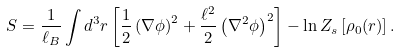<formula> <loc_0><loc_0><loc_500><loc_500>S = \frac { 1 } { \ell _ { B } } \int d ^ { 3 } r \left [ \frac { 1 } { 2 } \left ( \nabla \phi \right ) ^ { 2 } + \frac { \ell ^ { 2 } } { 2 } \left ( \nabla ^ { 2 } \phi \right ) ^ { 2 } \right ] - \ln Z _ { s } \left [ \rho _ { 0 } ( r ) \right ] .</formula> 